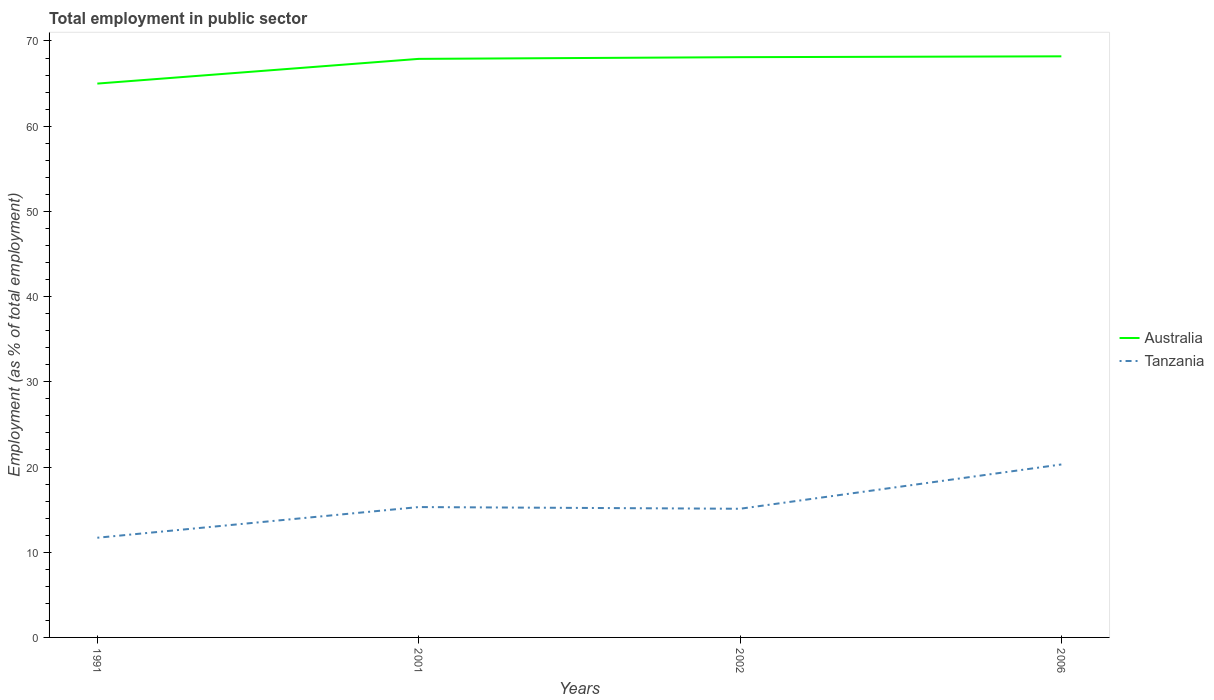How many different coloured lines are there?
Provide a short and direct response. 2. Does the line corresponding to Tanzania intersect with the line corresponding to Australia?
Make the answer very short. No. Across all years, what is the maximum employment in public sector in Australia?
Your answer should be very brief. 65. In which year was the employment in public sector in Tanzania maximum?
Make the answer very short. 1991. What is the total employment in public sector in Australia in the graph?
Ensure brevity in your answer.  -3.1. What is the difference between the highest and the second highest employment in public sector in Australia?
Offer a terse response. 3.2. What is the difference between the highest and the lowest employment in public sector in Australia?
Offer a terse response. 3. How many lines are there?
Keep it short and to the point. 2. What is the difference between two consecutive major ticks on the Y-axis?
Provide a short and direct response. 10. Does the graph contain any zero values?
Keep it short and to the point. No. What is the title of the graph?
Keep it short and to the point. Total employment in public sector. Does "Swaziland" appear as one of the legend labels in the graph?
Offer a terse response. No. What is the label or title of the X-axis?
Offer a very short reply. Years. What is the label or title of the Y-axis?
Give a very brief answer. Employment (as % of total employment). What is the Employment (as % of total employment) in Tanzania in 1991?
Provide a short and direct response. 11.7. What is the Employment (as % of total employment) of Australia in 2001?
Offer a terse response. 67.9. What is the Employment (as % of total employment) of Tanzania in 2001?
Provide a short and direct response. 15.3. What is the Employment (as % of total employment) in Australia in 2002?
Your response must be concise. 68.1. What is the Employment (as % of total employment) in Tanzania in 2002?
Make the answer very short. 15.1. What is the Employment (as % of total employment) of Australia in 2006?
Make the answer very short. 68.2. What is the Employment (as % of total employment) of Tanzania in 2006?
Your answer should be compact. 20.3. Across all years, what is the maximum Employment (as % of total employment) of Australia?
Provide a succinct answer. 68.2. Across all years, what is the maximum Employment (as % of total employment) of Tanzania?
Your response must be concise. 20.3. Across all years, what is the minimum Employment (as % of total employment) of Australia?
Offer a very short reply. 65. Across all years, what is the minimum Employment (as % of total employment) in Tanzania?
Give a very brief answer. 11.7. What is the total Employment (as % of total employment) in Australia in the graph?
Provide a succinct answer. 269.2. What is the total Employment (as % of total employment) in Tanzania in the graph?
Your answer should be very brief. 62.4. What is the difference between the Employment (as % of total employment) in Tanzania in 1991 and that in 2001?
Your answer should be very brief. -3.6. What is the difference between the Employment (as % of total employment) in Tanzania in 1991 and that in 2002?
Your answer should be very brief. -3.4. What is the difference between the Employment (as % of total employment) in Australia in 1991 and that in 2006?
Your answer should be compact. -3.2. What is the difference between the Employment (as % of total employment) of Tanzania in 1991 and that in 2006?
Give a very brief answer. -8.6. What is the difference between the Employment (as % of total employment) in Tanzania in 2001 and that in 2006?
Offer a terse response. -5. What is the difference between the Employment (as % of total employment) of Australia in 1991 and the Employment (as % of total employment) of Tanzania in 2001?
Give a very brief answer. 49.7. What is the difference between the Employment (as % of total employment) of Australia in 1991 and the Employment (as % of total employment) of Tanzania in 2002?
Keep it short and to the point. 49.9. What is the difference between the Employment (as % of total employment) of Australia in 1991 and the Employment (as % of total employment) of Tanzania in 2006?
Provide a short and direct response. 44.7. What is the difference between the Employment (as % of total employment) of Australia in 2001 and the Employment (as % of total employment) of Tanzania in 2002?
Give a very brief answer. 52.8. What is the difference between the Employment (as % of total employment) of Australia in 2001 and the Employment (as % of total employment) of Tanzania in 2006?
Your answer should be compact. 47.6. What is the difference between the Employment (as % of total employment) in Australia in 2002 and the Employment (as % of total employment) in Tanzania in 2006?
Offer a very short reply. 47.8. What is the average Employment (as % of total employment) in Australia per year?
Make the answer very short. 67.3. What is the average Employment (as % of total employment) of Tanzania per year?
Offer a very short reply. 15.6. In the year 1991, what is the difference between the Employment (as % of total employment) in Australia and Employment (as % of total employment) in Tanzania?
Your answer should be very brief. 53.3. In the year 2001, what is the difference between the Employment (as % of total employment) of Australia and Employment (as % of total employment) of Tanzania?
Your answer should be compact. 52.6. In the year 2006, what is the difference between the Employment (as % of total employment) of Australia and Employment (as % of total employment) of Tanzania?
Ensure brevity in your answer.  47.9. What is the ratio of the Employment (as % of total employment) in Australia in 1991 to that in 2001?
Make the answer very short. 0.96. What is the ratio of the Employment (as % of total employment) of Tanzania in 1991 to that in 2001?
Your response must be concise. 0.76. What is the ratio of the Employment (as % of total employment) in Australia in 1991 to that in 2002?
Give a very brief answer. 0.95. What is the ratio of the Employment (as % of total employment) in Tanzania in 1991 to that in 2002?
Offer a terse response. 0.77. What is the ratio of the Employment (as % of total employment) of Australia in 1991 to that in 2006?
Your response must be concise. 0.95. What is the ratio of the Employment (as % of total employment) in Tanzania in 1991 to that in 2006?
Make the answer very short. 0.58. What is the ratio of the Employment (as % of total employment) of Australia in 2001 to that in 2002?
Your response must be concise. 1. What is the ratio of the Employment (as % of total employment) in Tanzania in 2001 to that in 2002?
Provide a succinct answer. 1.01. What is the ratio of the Employment (as % of total employment) in Australia in 2001 to that in 2006?
Make the answer very short. 1. What is the ratio of the Employment (as % of total employment) of Tanzania in 2001 to that in 2006?
Offer a terse response. 0.75. What is the ratio of the Employment (as % of total employment) in Australia in 2002 to that in 2006?
Your answer should be compact. 1. What is the ratio of the Employment (as % of total employment) of Tanzania in 2002 to that in 2006?
Your response must be concise. 0.74. 